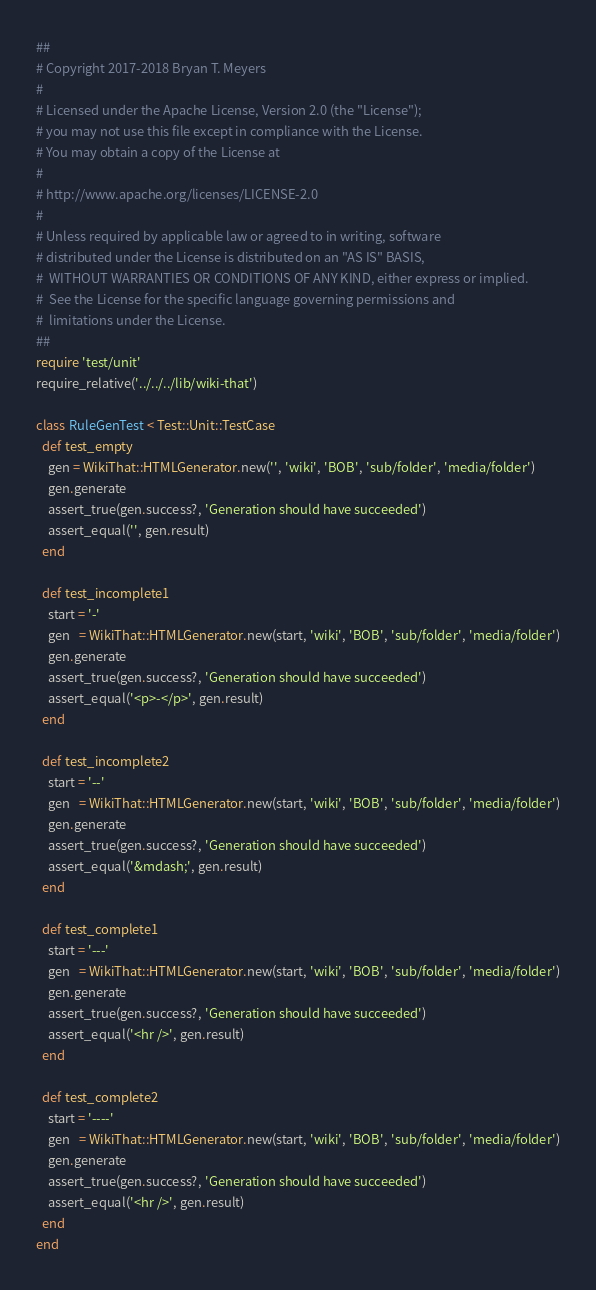<code> <loc_0><loc_0><loc_500><loc_500><_Ruby_>##
# Copyright 2017-2018 Bryan T. Meyers
#
# Licensed under the Apache License, Version 2.0 (the "License");
# you may not use this file except in compliance with the License.
# You may obtain a copy of the License at
#
# http://www.apache.org/licenses/LICENSE-2.0
#
# Unless required by applicable law or agreed to in writing, software
# distributed under the License is distributed on an "AS IS" BASIS,
#  WITHOUT WARRANTIES OR CONDITIONS OF ANY KIND, either express or implied.
#  See the License for the specific language governing permissions and
#  limitations under the License.
##
require 'test/unit'
require_relative('../../../lib/wiki-that')

class RuleGenTest < Test::Unit::TestCase
  def test_empty
    gen = WikiThat::HTMLGenerator.new('', 'wiki', 'BOB', 'sub/folder', 'media/folder')
    gen.generate
    assert_true(gen.success?, 'Generation should have succeeded')
    assert_equal('', gen.result)
  end

  def test_incomplete1
    start = '-'
    gen   = WikiThat::HTMLGenerator.new(start, 'wiki', 'BOB', 'sub/folder', 'media/folder')
    gen.generate
    assert_true(gen.success?, 'Generation should have succeeded')
    assert_equal('<p>-</p>', gen.result)
  end

  def test_incomplete2
    start = '--'
    gen   = WikiThat::HTMLGenerator.new(start, 'wiki', 'BOB', 'sub/folder', 'media/folder')
    gen.generate
    assert_true(gen.success?, 'Generation should have succeeded')
    assert_equal('&mdash;', gen.result)
  end

  def test_complete1
    start = '---'
    gen   = WikiThat::HTMLGenerator.new(start, 'wiki', 'BOB', 'sub/folder', 'media/folder')
    gen.generate
    assert_true(gen.success?, 'Generation should have succeeded')
    assert_equal('<hr />', gen.result)
  end

  def test_complete2
    start = '----'
    gen   = WikiThat::HTMLGenerator.new(start, 'wiki', 'BOB', 'sub/folder', 'media/folder')
    gen.generate
    assert_true(gen.success?, 'Generation should have succeeded')
    assert_equal('<hr />', gen.result)
  end
end
</code> 